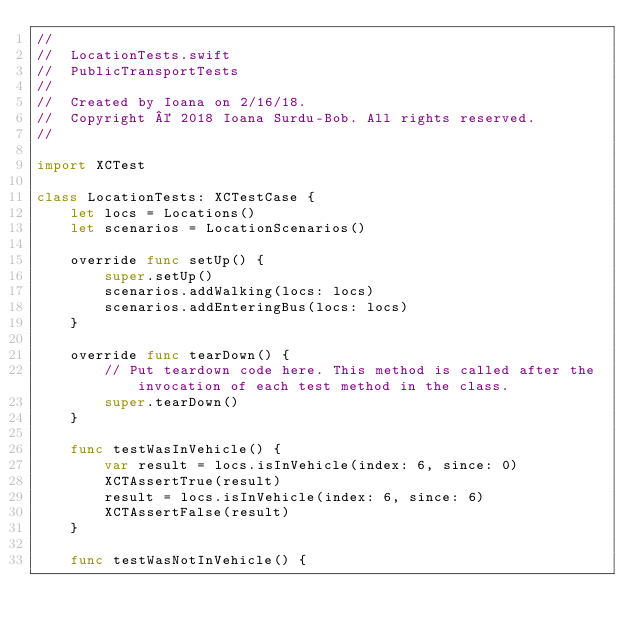<code> <loc_0><loc_0><loc_500><loc_500><_Swift_>//
//  LocationTests.swift
//  PublicTransportTests
//
//  Created by Ioana on 2/16/18.
//  Copyright © 2018 Ioana Surdu-Bob. All rights reserved.
//

import XCTest

class LocationTests: XCTestCase {
    let locs = Locations()
    let scenarios = LocationScenarios()
    
    override func setUp() {
        super.setUp()
        scenarios.addWalking(locs: locs)
        scenarios.addEnteringBus(locs: locs)
    }
    
    override func tearDown() {
        // Put teardown code here. This method is called after the invocation of each test method in the class.
        super.tearDown()
    }
    
    func testWasInVehicle() {
        var result = locs.isInVehicle(index: 6, since: 0)
        XCTAssertTrue(result)
        result = locs.isInVehicle(index: 6, since: 6)
        XCTAssertFalse(result)
    }
    
    func testWasNotInVehicle() {</code> 